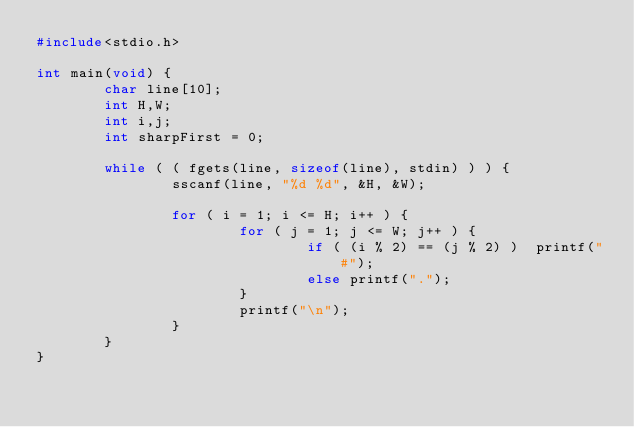<code> <loc_0><loc_0><loc_500><loc_500><_C_>#include<stdio.h>

int main(void) {
        char line[10];
        int H,W;
        int i,j;
        int sharpFirst = 0;

        while ( ( fgets(line, sizeof(line), stdin) ) ) {
                sscanf(line, "%d %d", &H, &W);

                for ( i = 1; i <= H; i++ ) {
                        for ( j = 1; j <= W; j++ ) {
                                if ( (i % 2) == (j % 2) )  printf("#");
                                else printf(".");
                        }
                        printf("\n");
                }
        }
}</code> 